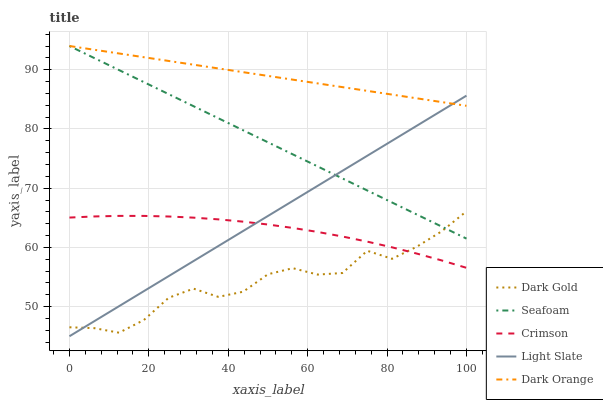Does Light Slate have the minimum area under the curve?
Answer yes or no. No. Does Light Slate have the maximum area under the curve?
Answer yes or no. No. Is Light Slate the smoothest?
Answer yes or no. No. Is Light Slate the roughest?
Answer yes or no. No. Does Seafoam have the lowest value?
Answer yes or no. No. Does Light Slate have the highest value?
Answer yes or no. No. Is Dark Gold less than Dark Orange?
Answer yes or no. Yes. Is Dark Orange greater than Crimson?
Answer yes or no. Yes. Does Dark Gold intersect Dark Orange?
Answer yes or no. No. 